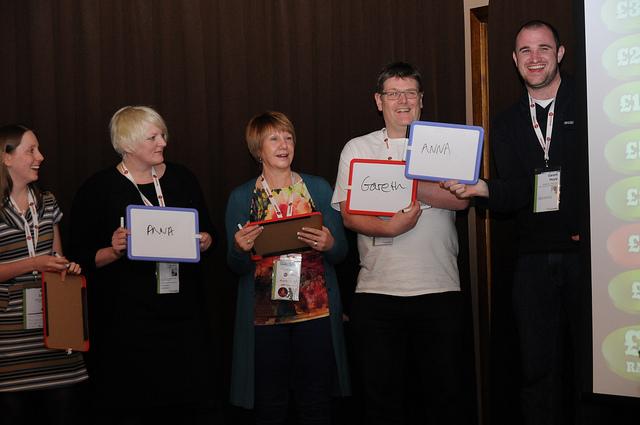Are they introducing themselves?
Keep it brief. Yes. What are the tags for?
Short answer required. Names. Which man is dressed the most casual?
Answer briefly. Second from right. Which person has blonde hair?
Short answer required. 2nd from left. Which country was hosting the event?
Answer briefly. America. What are these people holding?
Short answer required. Signs. 